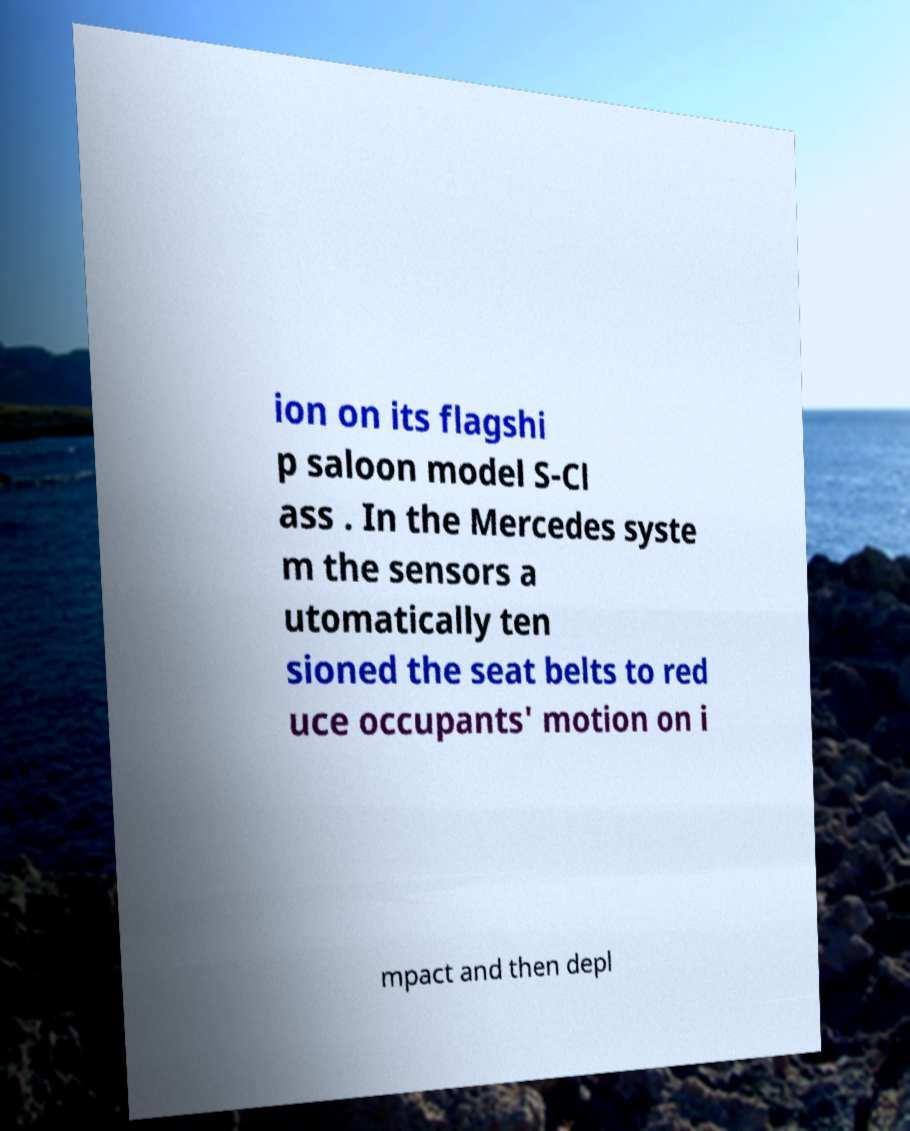Can you accurately transcribe the text from the provided image for me? ion on its flagshi p saloon model S-Cl ass . In the Mercedes syste m the sensors a utomatically ten sioned the seat belts to red uce occupants' motion on i mpact and then depl 